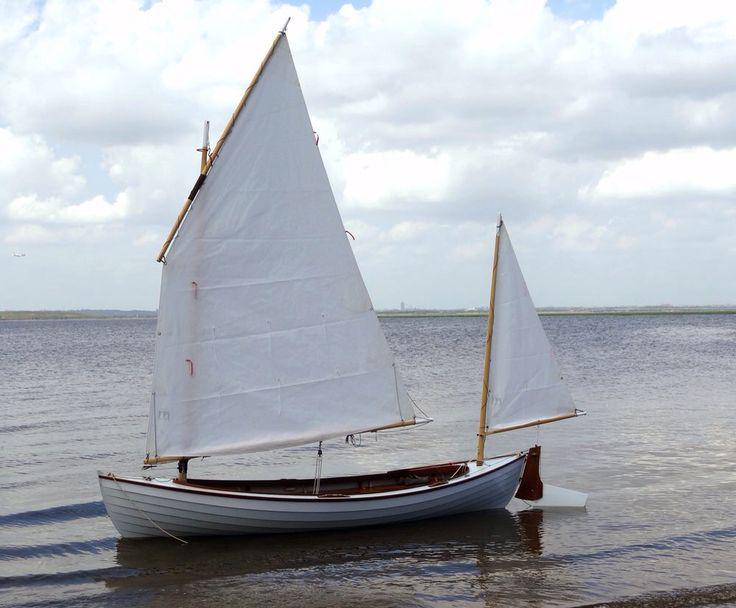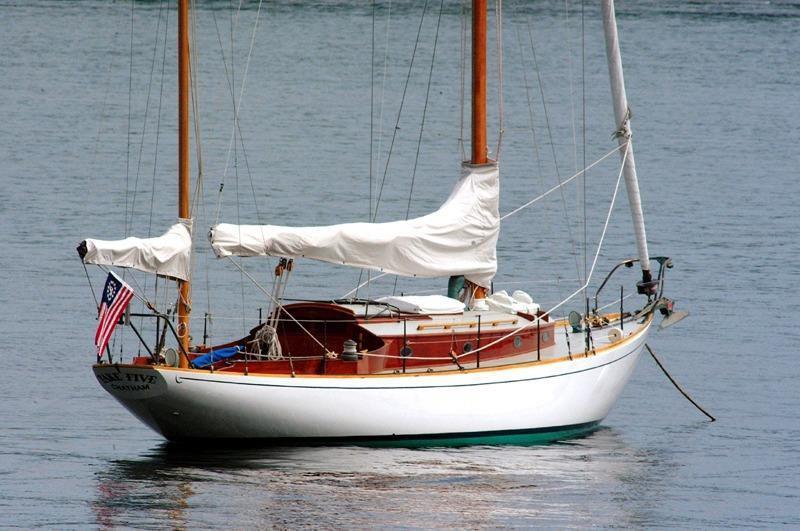The first image is the image on the left, the second image is the image on the right. For the images shown, is this caption "Trees can be seen in the background of the image on the left." true? Answer yes or no. No. 